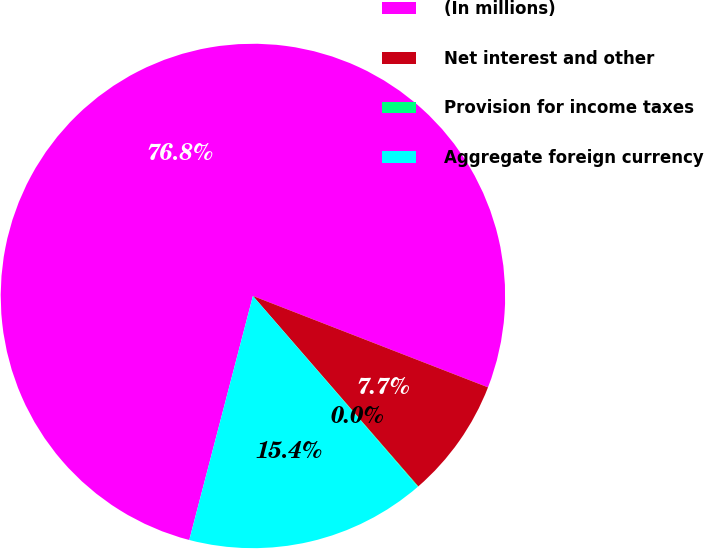<chart> <loc_0><loc_0><loc_500><loc_500><pie_chart><fcel>(In millions)<fcel>Net interest and other<fcel>Provision for income taxes<fcel>Aggregate foreign currency<nl><fcel>76.84%<fcel>7.72%<fcel>0.04%<fcel>15.4%<nl></chart> 